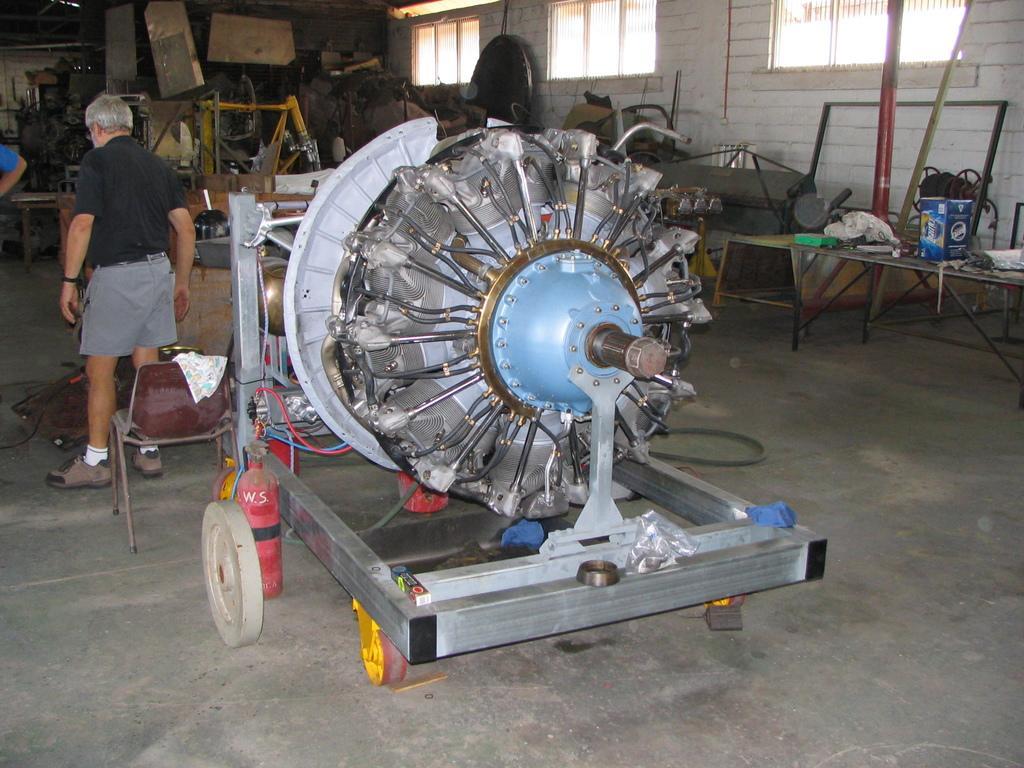Could you give a brief overview of what you see in this image? In this image I can see in the middle it is the motor, on the left side a man is there, he wore black color t-shirt. On the right side there are windows. 